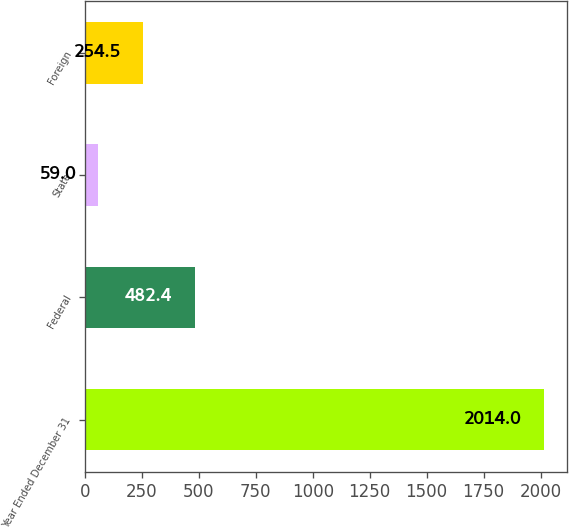Convert chart to OTSL. <chart><loc_0><loc_0><loc_500><loc_500><bar_chart><fcel>Year Ended December 31<fcel>Federal<fcel>State<fcel>Foreign<nl><fcel>2014<fcel>482.4<fcel>59<fcel>254.5<nl></chart> 